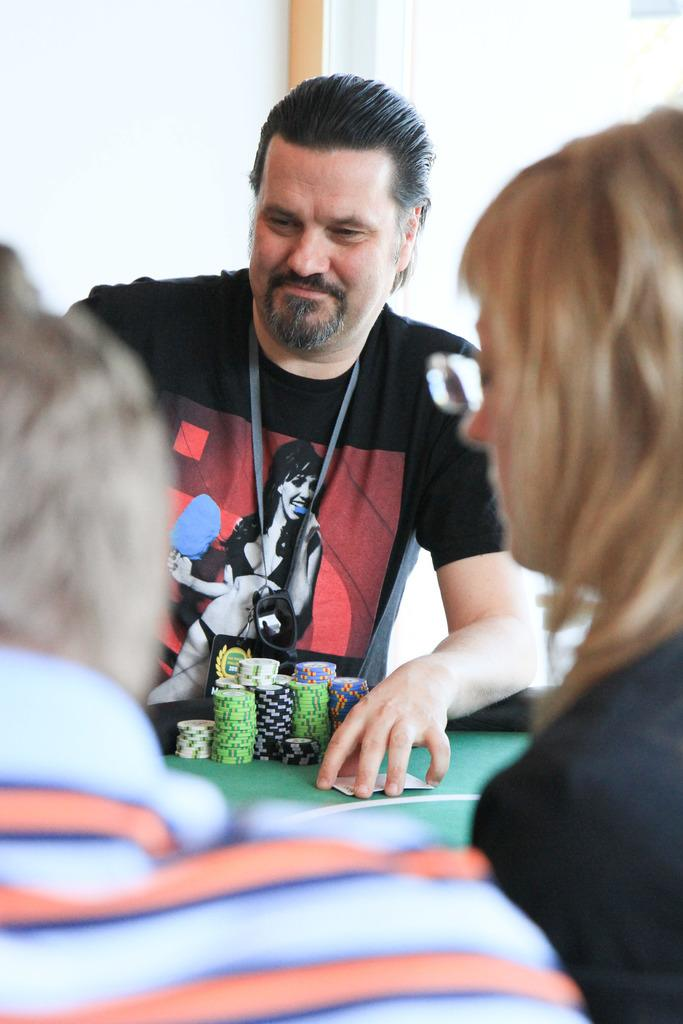How many people are in the image? There are persons standing in the image. What is present on the table in the image? There are coins and a card on the table. What is the material of the table in the image? The material of the table is not mentioned in the facts, so we cannot determine it. What can be seen in the background of the image? There is a wall in the background of the image. What object is made of wood in the image? There is a wooden stick in the image. How many wings are visible on the persons in the image? There is no mention of wings in the image, so we cannot determine the number of wings. What type of rabbit can be seen on the table in the image? There is no rabbit present on the table or in the image. 